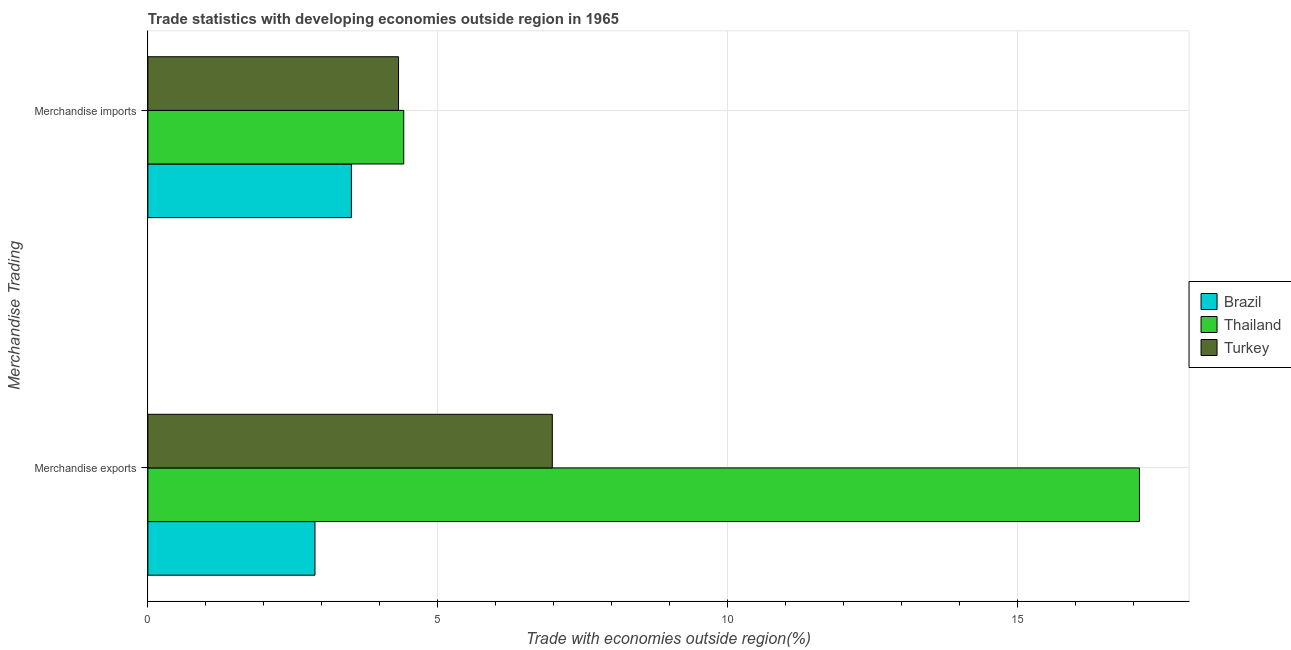How many different coloured bars are there?
Give a very brief answer. 3. How many groups of bars are there?
Offer a very short reply. 2. How many bars are there on the 1st tick from the top?
Ensure brevity in your answer.  3. What is the merchandise imports in Brazil?
Provide a succinct answer. 3.51. Across all countries, what is the maximum merchandise imports?
Your answer should be very brief. 4.42. Across all countries, what is the minimum merchandise imports?
Offer a terse response. 3.51. In which country was the merchandise exports maximum?
Your response must be concise. Thailand. In which country was the merchandise exports minimum?
Provide a succinct answer. Brazil. What is the total merchandise imports in the graph?
Ensure brevity in your answer.  12.25. What is the difference between the merchandise imports in Brazil and that in Turkey?
Give a very brief answer. -0.81. What is the difference between the merchandise exports in Turkey and the merchandise imports in Brazil?
Provide a succinct answer. 3.47. What is the average merchandise exports per country?
Offer a terse response. 8.99. What is the difference between the merchandise imports and merchandise exports in Brazil?
Give a very brief answer. 0.63. In how many countries, is the merchandise exports greater than 15 %?
Provide a short and direct response. 1. What is the ratio of the merchandise imports in Turkey to that in Thailand?
Your response must be concise. 0.98. Is the merchandise exports in Thailand less than that in Turkey?
Give a very brief answer. No. In how many countries, is the merchandise imports greater than the average merchandise imports taken over all countries?
Ensure brevity in your answer.  2. What does the 2nd bar from the top in Merchandise imports represents?
Offer a very short reply. Thailand. What does the 2nd bar from the bottom in Merchandise imports represents?
Offer a terse response. Thailand. Are all the bars in the graph horizontal?
Provide a short and direct response. Yes. How many countries are there in the graph?
Make the answer very short. 3. What is the difference between two consecutive major ticks on the X-axis?
Your answer should be very brief. 5. Are the values on the major ticks of X-axis written in scientific E-notation?
Provide a succinct answer. No. How are the legend labels stacked?
Your answer should be very brief. Vertical. What is the title of the graph?
Provide a short and direct response. Trade statistics with developing economies outside region in 1965. Does "Singapore" appear as one of the legend labels in the graph?
Give a very brief answer. No. What is the label or title of the X-axis?
Give a very brief answer. Trade with economies outside region(%). What is the label or title of the Y-axis?
Keep it short and to the point. Merchandise Trading. What is the Trade with economies outside region(%) in Brazil in Merchandise exports?
Offer a terse response. 2.88. What is the Trade with economies outside region(%) in Thailand in Merchandise exports?
Provide a succinct answer. 17.11. What is the Trade with economies outside region(%) in Turkey in Merchandise exports?
Offer a very short reply. 6.98. What is the Trade with economies outside region(%) in Brazil in Merchandise imports?
Offer a very short reply. 3.51. What is the Trade with economies outside region(%) in Thailand in Merchandise imports?
Give a very brief answer. 4.42. What is the Trade with economies outside region(%) in Turkey in Merchandise imports?
Provide a succinct answer. 4.33. Across all Merchandise Trading, what is the maximum Trade with economies outside region(%) of Brazil?
Offer a terse response. 3.51. Across all Merchandise Trading, what is the maximum Trade with economies outside region(%) of Thailand?
Offer a very short reply. 17.11. Across all Merchandise Trading, what is the maximum Trade with economies outside region(%) of Turkey?
Provide a succinct answer. 6.98. Across all Merchandise Trading, what is the minimum Trade with economies outside region(%) of Brazil?
Keep it short and to the point. 2.88. Across all Merchandise Trading, what is the minimum Trade with economies outside region(%) in Thailand?
Offer a terse response. 4.42. Across all Merchandise Trading, what is the minimum Trade with economies outside region(%) in Turkey?
Provide a short and direct response. 4.33. What is the total Trade with economies outside region(%) in Brazil in the graph?
Make the answer very short. 6.4. What is the total Trade with economies outside region(%) in Thailand in the graph?
Make the answer very short. 21.53. What is the total Trade with economies outside region(%) of Turkey in the graph?
Ensure brevity in your answer.  11.31. What is the difference between the Trade with economies outside region(%) in Brazil in Merchandise exports and that in Merchandise imports?
Your response must be concise. -0.63. What is the difference between the Trade with economies outside region(%) of Thailand in Merchandise exports and that in Merchandise imports?
Ensure brevity in your answer.  12.7. What is the difference between the Trade with economies outside region(%) of Turkey in Merchandise exports and that in Merchandise imports?
Give a very brief answer. 2.65. What is the difference between the Trade with economies outside region(%) in Brazil in Merchandise exports and the Trade with economies outside region(%) in Thailand in Merchandise imports?
Offer a terse response. -1.53. What is the difference between the Trade with economies outside region(%) of Brazil in Merchandise exports and the Trade with economies outside region(%) of Turkey in Merchandise imports?
Give a very brief answer. -1.44. What is the difference between the Trade with economies outside region(%) in Thailand in Merchandise exports and the Trade with economies outside region(%) in Turkey in Merchandise imports?
Make the answer very short. 12.79. What is the average Trade with economies outside region(%) of Brazil per Merchandise Trading?
Ensure brevity in your answer.  3.2. What is the average Trade with economies outside region(%) of Thailand per Merchandise Trading?
Make the answer very short. 10.76. What is the average Trade with economies outside region(%) of Turkey per Merchandise Trading?
Provide a short and direct response. 5.65. What is the difference between the Trade with economies outside region(%) in Brazil and Trade with economies outside region(%) in Thailand in Merchandise exports?
Your response must be concise. -14.23. What is the difference between the Trade with economies outside region(%) in Brazil and Trade with economies outside region(%) in Turkey in Merchandise exports?
Give a very brief answer. -4.1. What is the difference between the Trade with economies outside region(%) in Thailand and Trade with economies outside region(%) in Turkey in Merchandise exports?
Provide a short and direct response. 10.13. What is the difference between the Trade with economies outside region(%) in Brazil and Trade with economies outside region(%) in Thailand in Merchandise imports?
Make the answer very short. -0.9. What is the difference between the Trade with economies outside region(%) in Brazil and Trade with economies outside region(%) in Turkey in Merchandise imports?
Give a very brief answer. -0.81. What is the difference between the Trade with economies outside region(%) in Thailand and Trade with economies outside region(%) in Turkey in Merchandise imports?
Offer a terse response. 0.09. What is the ratio of the Trade with economies outside region(%) of Brazil in Merchandise exports to that in Merchandise imports?
Your response must be concise. 0.82. What is the ratio of the Trade with economies outside region(%) in Thailand in Merchandise exports to that in Merchandise imports?
Ensure brevity in your answer.  3.88. What is the ratio of the Trade with economies outside region(%) in Turkey in Merchandise exports to that in Merchandise imports?
Offer a terse response. 1.61. What is the difference between the highest and the second highest Trade with economies outside region(%) in Brazil?
Provide a succinct answer. 0.63. What is the difference between the highest and the second highest Trade with economies outside region(%) in Thailand?
Give a very brief answer. 12.7. What is the difference between the highest and the second highest Trade with economies outside region(%) in Turkey?
Provide a short and direct response. 2.65. What is the difference between the highest and the lowest Trade with economies outside region(%) in Brazil?
Offer a terse response. 0.63. What is the difference between the highest and the lowest Trade with economies outside region(%) of Thailand?
Offer a very short reply. 12.7. What is the difference between the highest and the lowest Trade with economies outside region(%) in Turkey?
Offer a terse response. 2.65. 